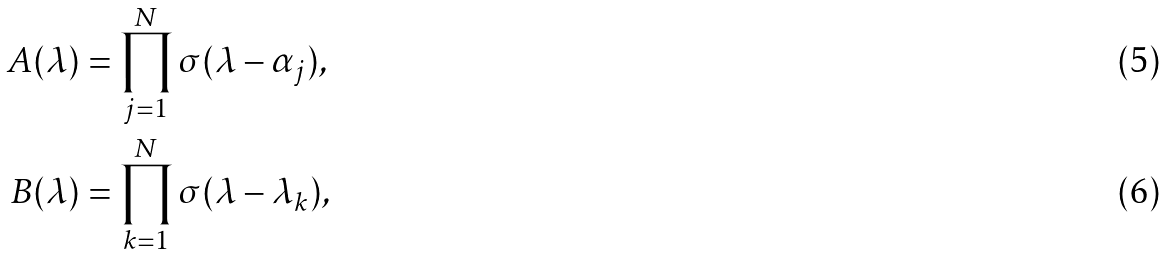Convert formula to latex. <formula><loc_0><loc_0><loc_500><loc_500>A ( \lambda ) & = \prod _ { j = 1 } ^ { N } \sigma ( \lambda - \alpha _ { j } ) , \\ B ( \lambda ) & = \prod _ { k = 1 } ^ { N } \sigma ( \lambda - \lambda _ { k } ) ,</formula> 